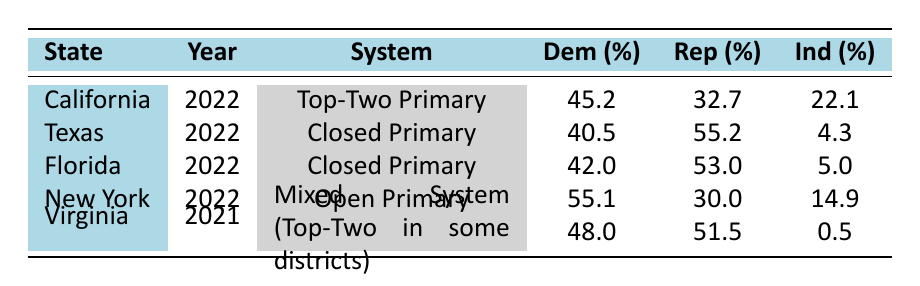What is the percentage of Democratic voters in California for the 2022 election? The table shows that in California under the Top-Two Primary system in 2022, the percentage of Democratic voters is listed as 45.2%.
Answer: 45.2 Which state had the highest percentage of Republican voters? By observing the poll results for the Republican candidates, Texas has a Republican voter percentage of 55.2%, which is higher than Florida (53.0%) and Virginia (51.5%). Therefore, Texas has the highest percentage of Republican voters.
Answer: Texas Is the Independent voter percentage higher in New York or California? In New York, the Independent voter percentage is 14.9%, while in California, it is 22.1%. Since 22.1% is greater than 14.9%, the Independent voter percentage is higher in California.
Answer: Yes, California has a higher percentage What is the total percentage of Democratic voters across all electoral systems in 2022? The Democratic voter percentages for 2022 are: California 45.2%, Texas 40.5%, Florida 42.0%, and New York 55.1%. Adding these together gives: 45.2 + 40.5 + 42.0 + 55.1 = 183.8%. The total percentage of Democratic voters is 183.8%.
Answer: 183.8 What is the average percentage of Independent voters across the states listed? The Independent voter percentages are: California 22.1%, Texas 4.3%, Florida 5.0%, New York 14.9%, and Virginia 0.5%. To find the average, first sum these percentages: 22.1 + 4.3 + 5.0 + 14.9 + 0.5 = 46.8%. Next, divide by the number of states (5): 46.8% / 5 = 9.36%. The average percentage of Independent voters is 9.36%.
Answer: 9.36 In the 2021 election in Virginia, did the Republican candidate receive more votes than the Democratic candidate? The table shows that in Virginia, the Republican candidate received 51.5% of the votes while the Democratic candidate received 48.0%. Since 51.5% is greater than 48.0%, the Republican candidate received more votes.
Answer: Yes, the Republican candidate received more votes 